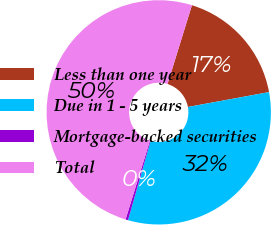<chart> <loc_0><loc_0><loc_500><loc_500><pie_chart><fcel>Less than one year<fcel>Due in 1 - 5 years<fcel>Mortgage-backed securities<fcel>Total<nl><fcel>17.33%<fcel>32.31%<fcel>0.36%<fcel>50.0%<nl></chart> 